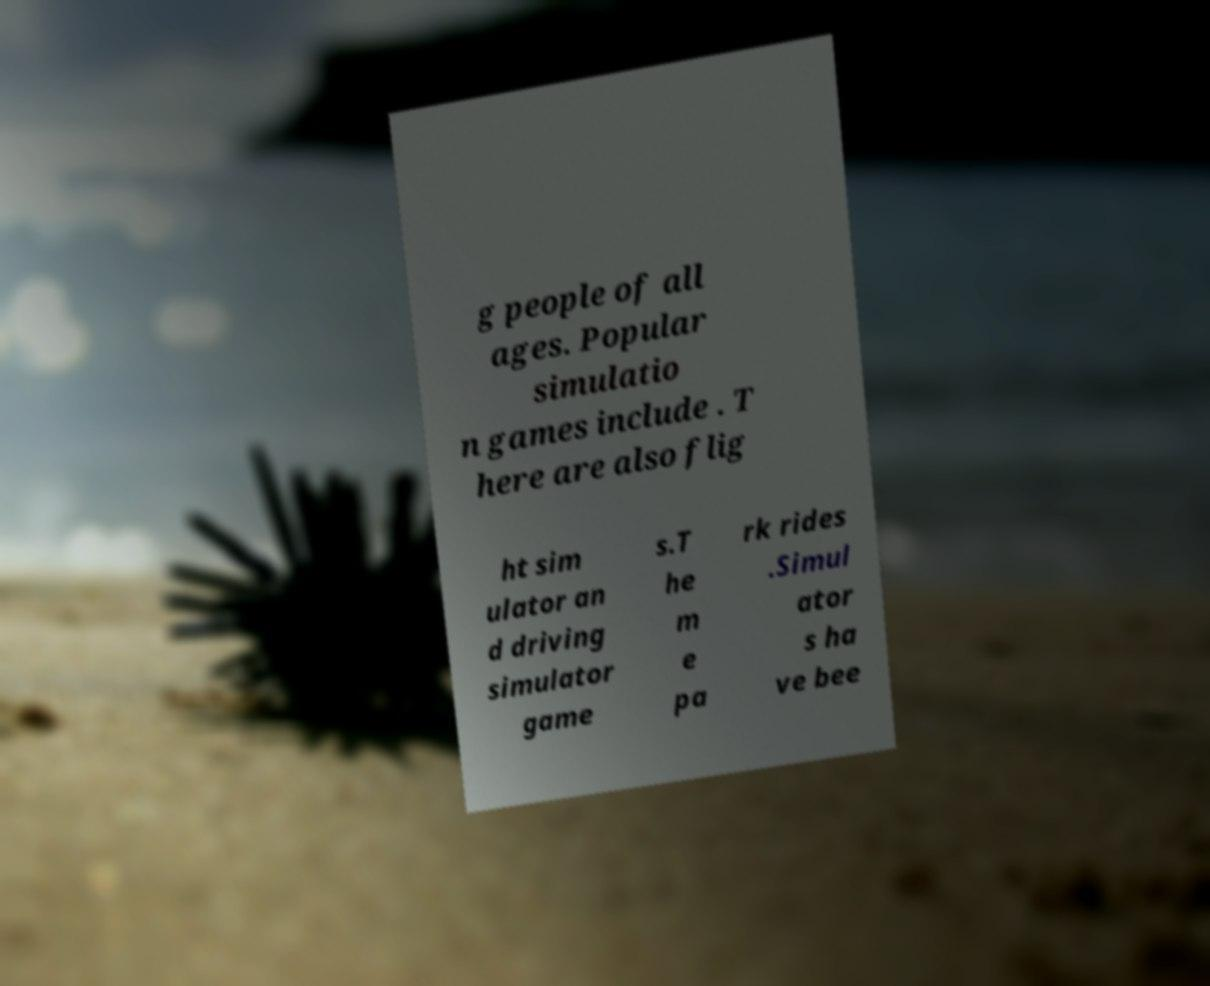What messages or text are displayed in this image? I need them in a readable, typed format. g people of all ages. Popular simulatio n games include . T here are also flig ht sim ulator an d driving simulator game s.T he m e pa rk rides .Simul ator s ha ve bee 